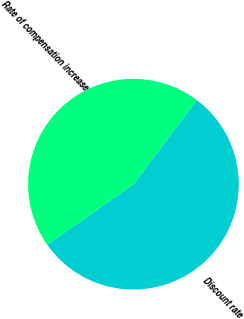Convert chart. <chart><loc_0><loc_0><loc_500><loc_500><pie_chart><fcel>Discount rate<fcel>Rate of compensation increase<nl><fcel>55.0%<fcel>45.0%<nl></chart> 